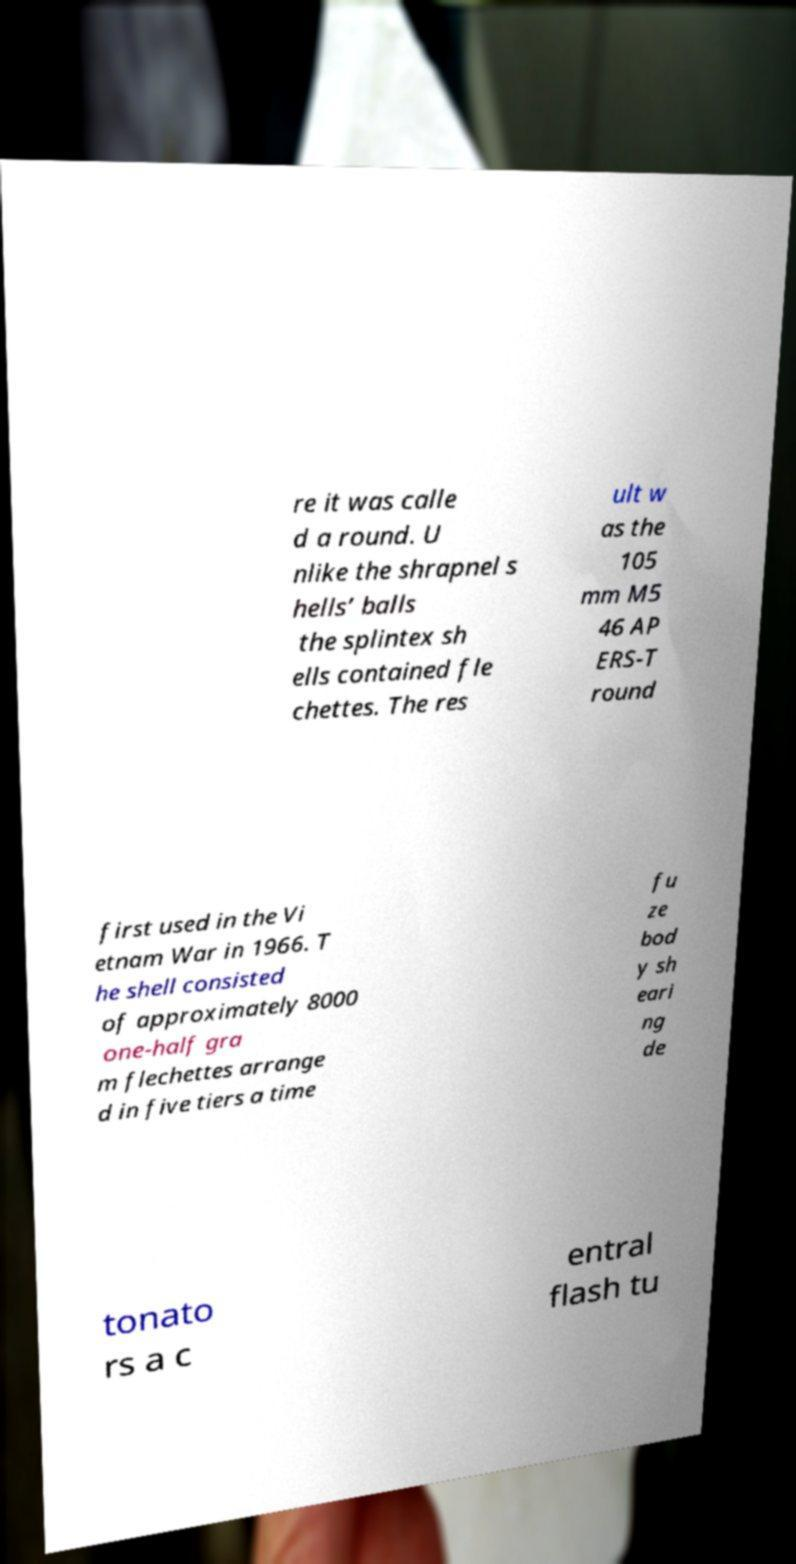There's text embedded in this image that I need extracted. Can you transcribe it verbatim? re it was calle d a round. U nlike the shrapnel s hells’ balls the splintex sh ells contained fle chettes. The res ult w as the 105 mm M5 46 AP ERS-T round first used in the Vi etnam War in 1966. T he shell consisted of approximately 8000 one-half gra m flechettes arrange d in five tiers a time fu ze bod y sh eari ng de tonato rs a c entral flash tu 